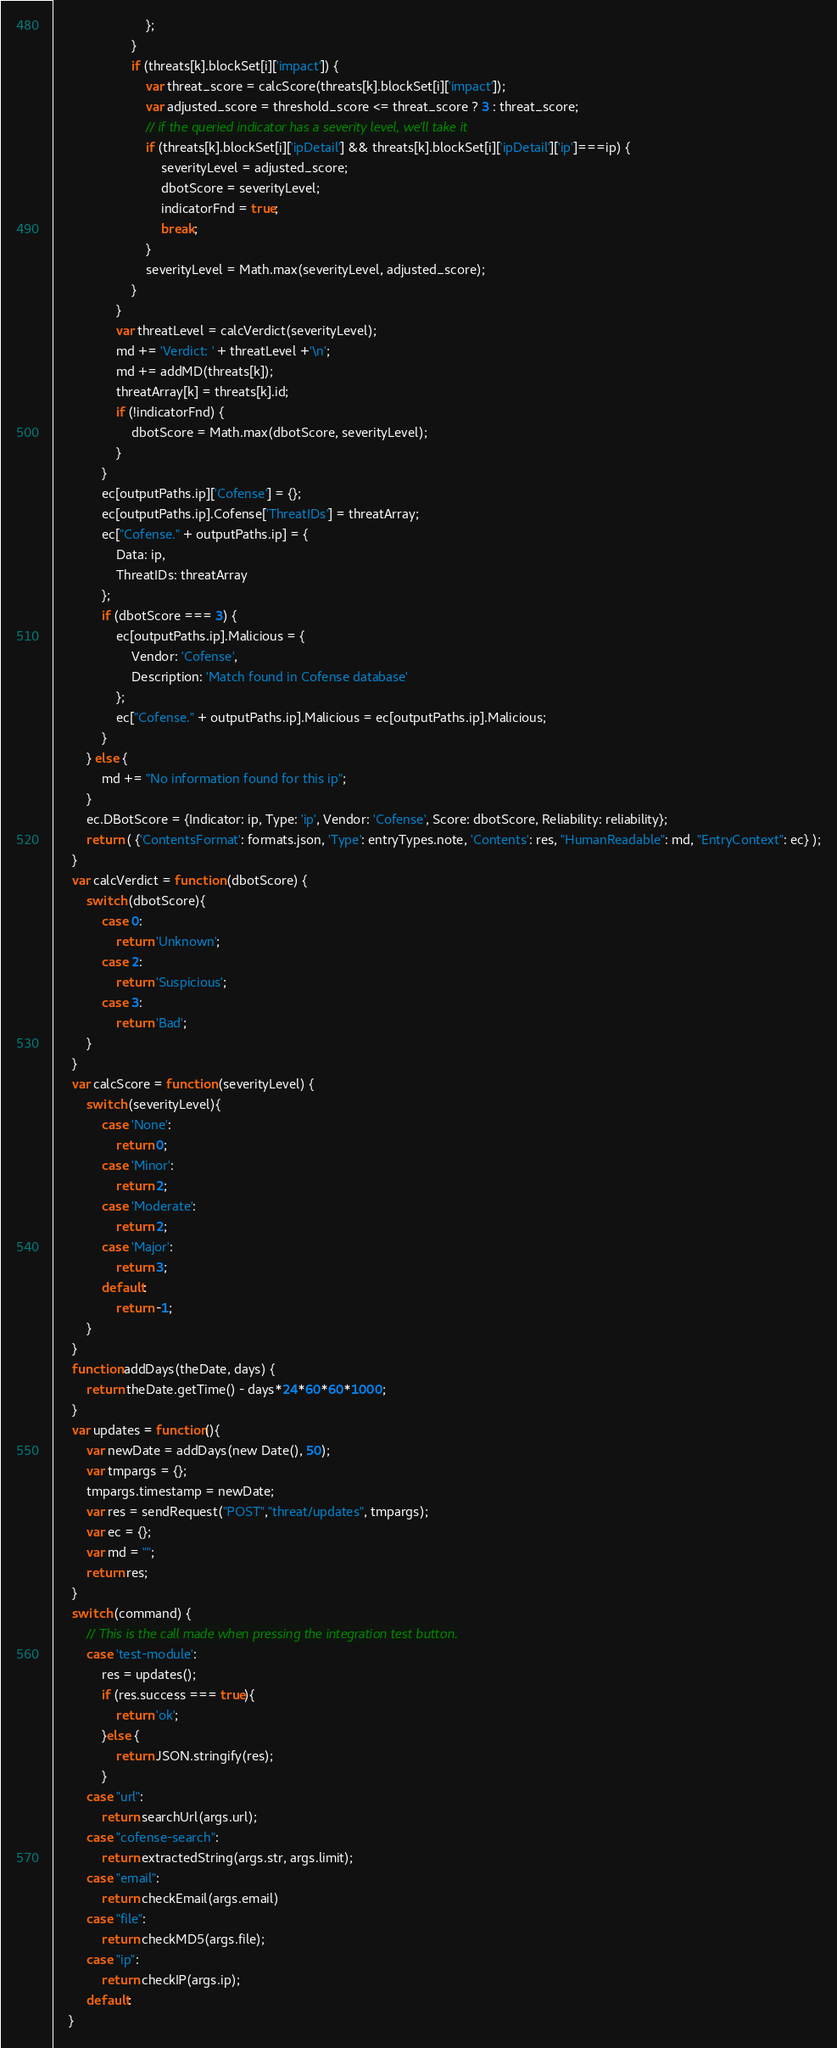<code> <loc_0><loc_0><loc_500><loc_500><_JavaScript_>                         };
                     }
                     if (threats[k].blockSet[i]['impact']) {
                         var threat_score = calcScore(threats[k].blockSet[i]['impact']);
                         var adjusted_score = threshold_score <= threat_score ? 3 : threat_score;
                         // if the queried indicator has a severity level, we'll take it
                         if (threats[k].blockSet[i]['ipDetail'] && threats[k].blockSet[i]['ipDetail']['ip']===ip) {
                             severityLevel = adjusted_score;
                             dbotScore = severityLevel;
                             indicatorFnd = true;
                             break;
                         }
                         severityLevel = Math.max(severityLevel, adjusted_score);
                     }
                 }
                 var threatLevel = calcVerdict(severityLevel);
                 md += 'Verdict: ' + threatLevel +'\n';
                 md += addMD(threats[k]);
                 threatArray[k] = threats[k].id;
                 if (!indicatorFnd) {
                     dbotScore = Math.max(dbotScore, severityLevel);
                 }
             }
             ec[outputPaths.ip]['Cofense'] = {};
             ec[outputPaths.ip].Cofense['ThreatIDs'] = threatArray;
             ec["Cofense." + outputPaths.ip] = {
                 Data: ip,
                 ThreatIDs: threatArray
             };
             if (dbotScore === 3) {
                 ec[outputPaths.ip].Malicious = {
                     Vendor: 'Cofense',
                     Description: 'Match found in Cofense database'
                 };
                 ec["Cofense." + outputPaths.ip].Malicious = ec[outputPaths.ip].Malicious;
             }
         } else {
             md += "No information found for this ip";
         }
         ec.DBotScore = {Indicator: ip, Type: 'ip', Vendor: 'Cofense', Score: dbotScore, Reliability: reliability};
         return ( {'ContentsFormat': formats.json, 'Type': entryTypes.note, 'Contents': res, "HumanReadable": md, "EntryContext": ec} );
     }
     var calcVerdict = function (dbotScore) {
         switch (dbotScore){
             case 0:
                 return 'Unknown';
             case 2:
                 return 'Suspicious';
             case 3:
                 return 'Bad';
         }
     }
     var calcScore = function (severityLevel) {
         switch (severityLevel){
             case 'None':
                 return 0;
             case 'Minor':
                 return 2;
             case 'Moderate':
                 return 2;
             case 'Major':
                 return 3;
             default:
                 return -1;
         }
     }
     function addDays(theDate, days) {
         return theDate.getTime() - days*24*60*60*1000;
     }
     var updates = function(){
         var newDate = addDays(new Date(), 50);
         var tmpargs = {};
         tmpargs.timestamp = newDate;
         var res = sendRequest("POST","threat/updates", tmpargs);
         var ec = {};
         var md = "";
         return res;
     }
     switch (command) {
         // This is the call made when pressing the integration test button.
         case 'test-module':
             res = updates();
             if (res.success === true){
                 return 'ok';
             }else {
                 return JSON.stringify(res);
             }
         case "url":
             return searchUrl(args.url);
         case "cofense-search":
             return extractedString(args.str, args.limit);
         case "email":
             return checkEmail(args.email)
         case "file":
             return checkMD5(args.file);
         case "ip":
             return checkIP(args.ip);
         default:
    }
</code> 